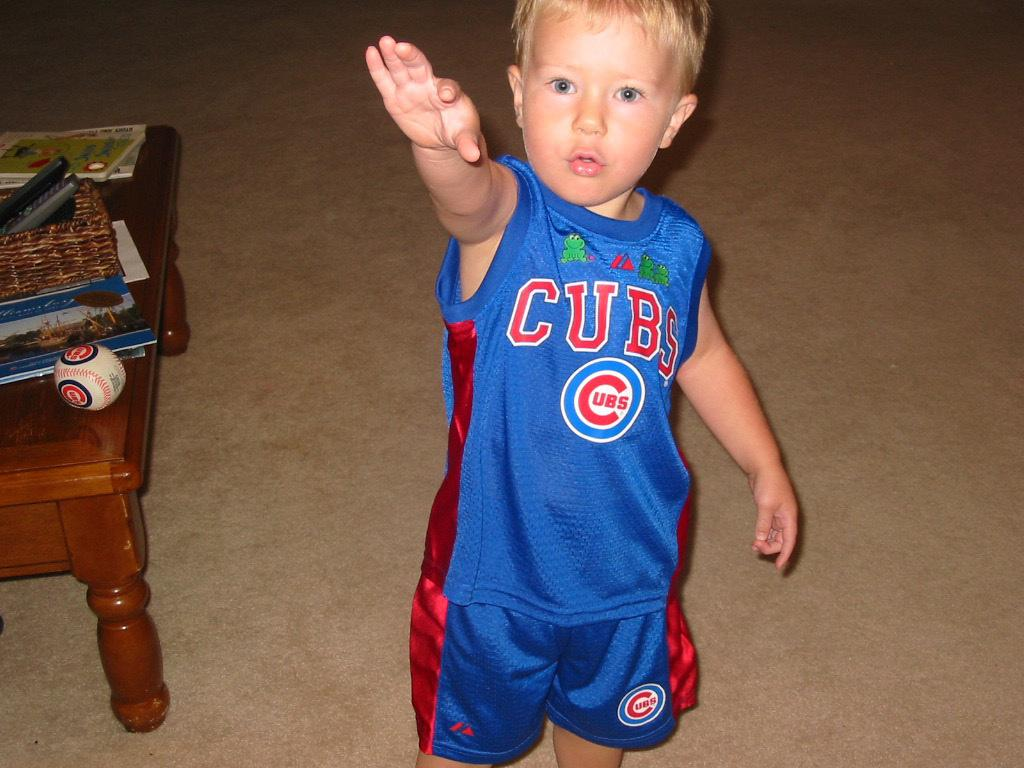Provide a one-sentence caption for the provided image. toddler wearing blue and red cubs shirt and shorts. 